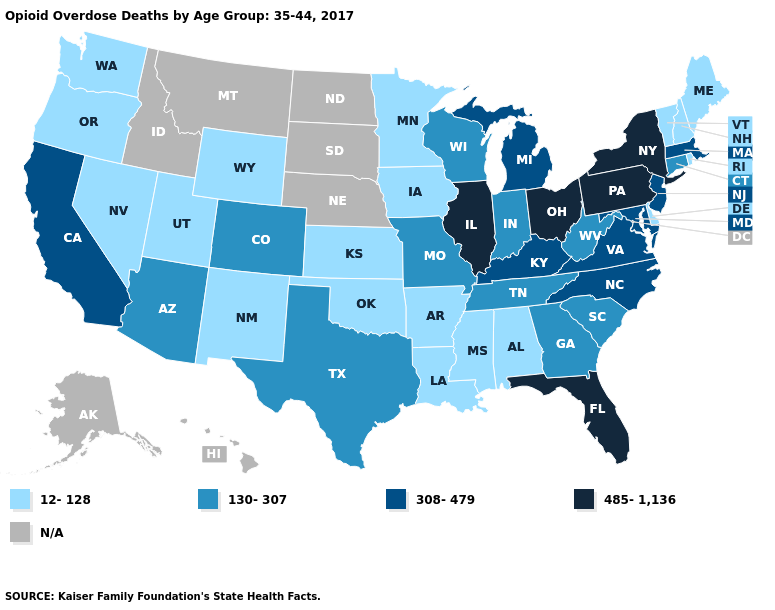What is the highest value in the USA?
Be succinct. 485-1,136. What is the value of Utah?
Give a very brief answer. 12-128. Which states have the highest value in the USA?
Be succinct. Florida, Illinois, New York, Ohio, Pennsylvania. Among the states that border Wyoming , which have the lowest value?
Keep it brief. Utah. Which states hav the highest value in the South?
Keep it brief. Florida. How many symbols are there in the legend?
Answer briefly. 5. What is the lowest value in states that border Arizona?
Keep it brief. 12-128. What is the lowest value in the Northeast?
Be succinct. 12-128. Does Florida have the highest value in the South?
Concise answer only. Yes. What is the lowest value in states that border Rhode Island?
Concise answer only. 130-307. Name the states that have a value in the range N/A?
Give a very brief answer. Alaska, Hawaii, Idaho, Montana, Nebraska, North Dakota, South Dakota. Which states have the lowest value in the Northeast?
Answer briefly. Maine, New Hampshire, Rhode Island, Vermont. Name the states that have a value in the range 308-479?
Quick response, please. California, Kentucky, Maryland, Massachusetts, Michigan, New Jersey, North Carolina, Virginia. Name the states that have a value in the range 308-479?
Be succinct. California, Kentucky, Maryland, Massachusetts, Michigan, New Jersey, North Carolina, Virginia. 